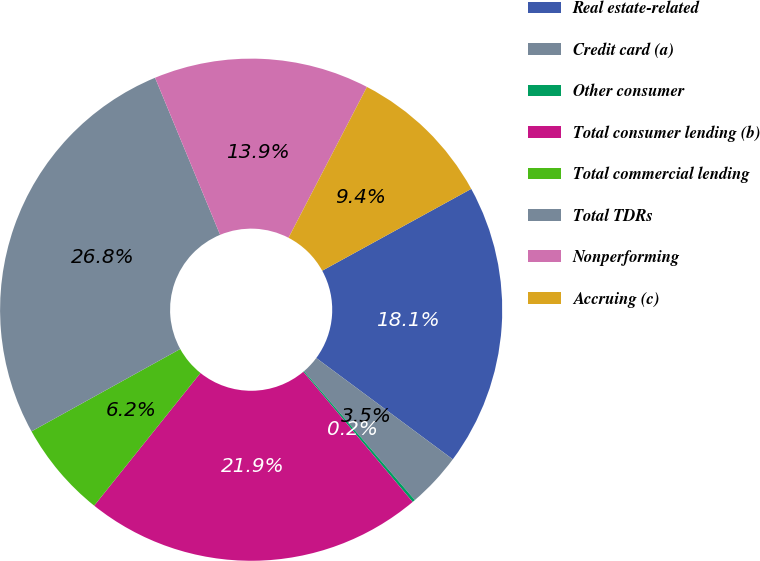<chart> <loc_0><loc_0><loc_500><loc_500><pie_chart><fcel>Real estate-related<fcel>Credit card (a)<fcel>Other consumer<fcel>Total consumer lending (b)<fcel>Total commercial lending<fcel>Total TDRs<fcel>Nonperforming<fcel>Accruing (c)<nl><fcel>18.15%<fcel>3.54%<fcel>0.18%<fcel>21.87%<fcel>6.2%<fcel>26.8%<fcel>13.88%<fcel>9.38%<nl></chart> 